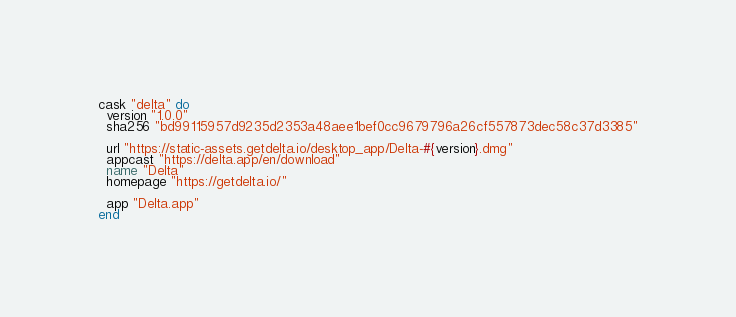<code> <loc_0><loc_0><loc_500><loc_500><_Ruby_>cask "delta" do
  version "1.0.0"
  sha256 "bd99115957d9235d2353a48aee1bef0cc9679796a26cf557873dec58c37d3385"

  url "https://static-assets.getdelta.io/desktop_app/Delta-#{version}.dmg"
  appcast "https://delta.app/en/download"
  name "Delta"
  homepage "https://getdelta.io/"

  app "Delta.app"
end
</code> 